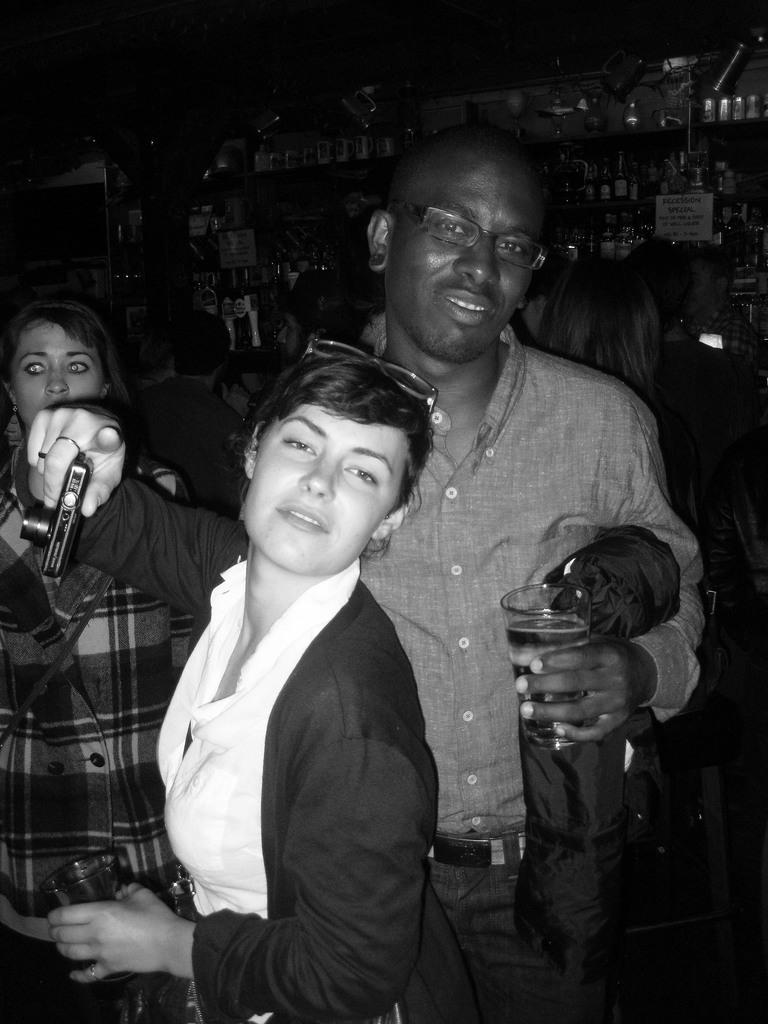What is the color scheme of the image? The image is black and white. How many women are in the image? There are two women in the image. Are there any men in the image? Yes, there is a man in the image. What is the man holding in his hand? The man is holding a glass in his hand. What type of jail is visible in the image? There is no jail present in the image. How does the man change the glass in the image? The man is not changing the glass in the image; he is simply holding it. 